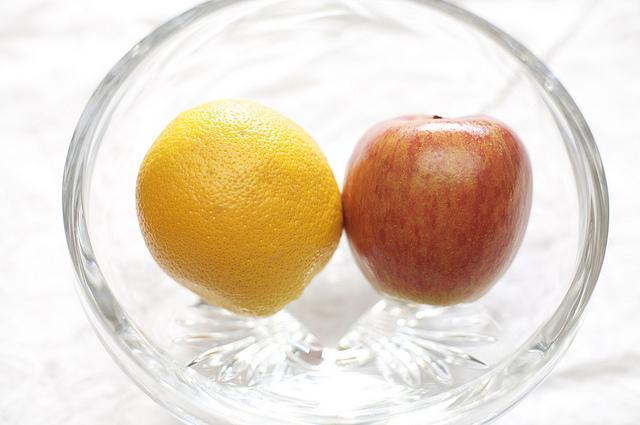How many fruits are in the bowl?
Give a very brief answer. 2. How many apples can you see?
Give a very brief answer. 1. How many people are in the photo?
Give a very brief answer. 0. 